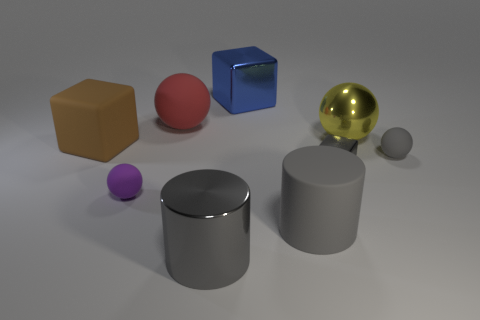The brown object is what shape?
Ensure brevity in your answer.  Cube. How many large red rubber things are in front of the large rubber sphere?
Make the answer very short. 0. What number of big blue blocks have the same material as the red object?
Your response must be concise. 0. Are the brown block that is to the left of the big red sphere and the small purple ball made of the same material?
Keep it short and to the point. Yes. Are any tiny metallic cylinders visible?
Ensure brevity in your answer.  No. How big is the rubber object that is behind the purple object and to the right of the gray shiny cylinder?
Give a very brief answer. Small. Is the number of large blue objects that are to the right of the yellow ball greater than the number of large brown rubber blocks that are left of the big matte cylinder?
Ensure brevity in your answer.  No. What is the size of the other cylinder that is the same color as the rubber cylinder?
Ensure brevity in your answer.  Large. The matte block is what color?
Your answer should be very brief. Brown. What is the color of the block that is in front of the red matte sphere and behind the gray matte ball?
Make the answer very short. Brown. 